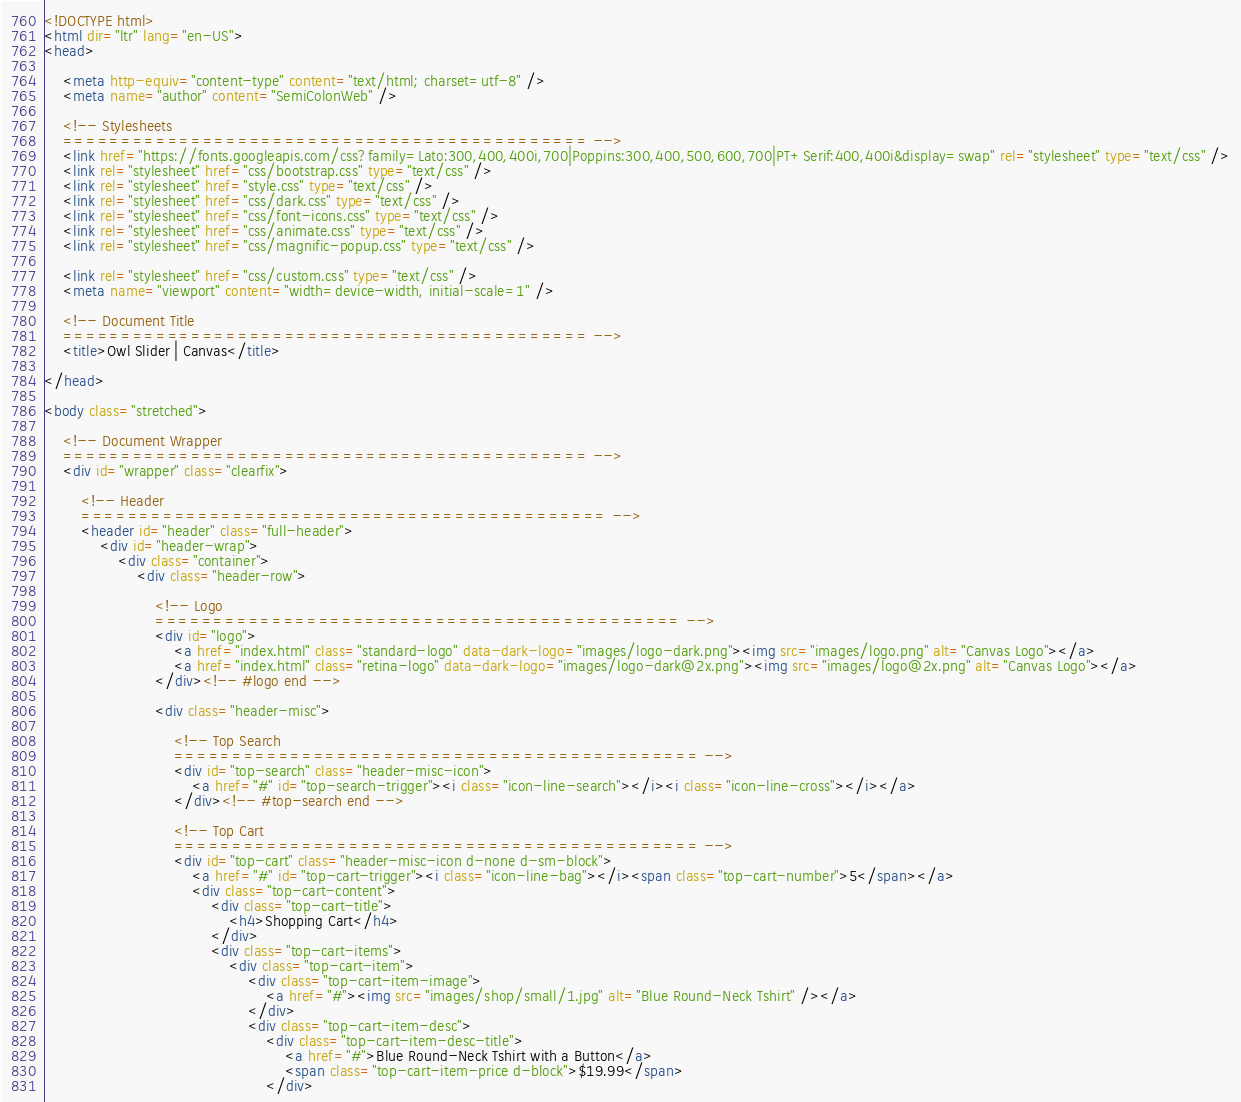<code> <loc_0><loc_0><loc_500><loc_500><_HTML_><!DOCTYPE html>
<html dir="ltr" lang="en-US">
<head>

	<meta http-equiv="content-type" content="text/html; charset=utf-8" />
	<meta name="author" content="SemiColonWeb" />

	<!-- Stylesheets
	============================================= -->
	<link href="https://fonts.googleapis.com/css?family=Lato:300,400,400i,700|Poppins:300,400,500,600,700|PT+Serif:400,400i&display=swap" rel="stylesheet" type="text/css" />
	<link rel="stylesheet" href="css/bootstrap.css" type="text/css" />
	<link rel="stylesheet" href="style.css" type="text/css" />
	<link rel="stylesheet" href="css/dark.css" type="text/css" />
	<link rel="stylesheet" href="css/font-icons.css" type="text/css" />
	<link rel="stylesheet" href="css/animate.css" type="text/css" />
	<link rel="stylesheet" href="css/magnific-popup.css" type="text/css" />

	<link rel="stylesheet" href="css/custom.css" type="text/css" />
	<meta name="viewport" content="width=device-width, initial-scale=1" />

	<!-- Document Title
	============================================= -->
	<title>Owl Slider | Canvas</title>

</head>

<body class="stretched">

	<!-- Document Wrapper
	============================================= -->
	<div id="wrapper" class="clearfix">

		<!-- Header
		============================================= -->
		<header id="header" class="full-header">
			<div id="header-wrap">
				<div class="container">
					<div class="header-row">

						<!-- Logo
						============================================= -->
						<div id="logo">
							<a href="index.html" class="standard-logo" data-dark-logo="images/logo-dark.png"><img src="images/logo.png" alt="Canvas Logo"></a>
							<a href="index.html" class="retina-logo" data-dark-logo="images/logo-dark@2x.png"><img src="images/logo@2x.png" alt="Canvas Logo"></a>
						</div><!-- #logo end -->

						<div class="header-misc">

							<!-- Top Search
							============================================= -->
							<div id="top-search" class="header-misc-icon">
								<a href="#" id="top-search-trigger"><i class="icon-line-search"></i><i class="icon-line-cross"></i></a>
							</div><!-- #top-search end -->

							<!-- Top Cart
							============================================= -->
							<div id="top-cart" class="header-misc-icon d-none d-sm-block">
								<a href="#" id="top-cart-trigger"><i class="icon-line-bag"></i><span class="top-cart-number">5</span></a>
								<div class="top-cart-content">
									<div class="top-cart-title">
										<h4>Shopping Cart</h4>
									</div>
									<div class="top-cart-items">
										<div class="top-cart-item">
											<div class="top-cart-item-image">
												<a href="#"><img src="images/shop/small/1.jpg" alt="Blue Round-Neck Tshirt" /></a>
											</div>
											<div class="top-cart-item-desc">
												<div class="top-cart-item-desc-title">
													<a href="#">Blue Round-Neck Tshirt with a Button</a>
													<span class="top-cart-item-price d-block">$19.99</span>
												</div></code> 